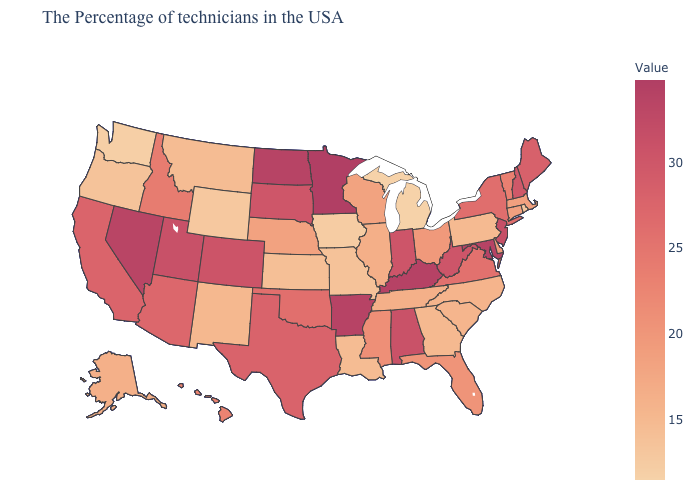Which states have the lowest value in the USA?
Keep it brief. Michigan. Does Delaware have the lowest value in the USA?
Give a very brief answer. No. Among the states that border North Carolina , does South Carolina have the lowest value?
Write a very short answer. No. Does Michigan have the lowest value in the USA?
Concise answer only. Yes. Is the legend a continuous bar?
Give a very brief answer. Yes. Does New Mexico have a higher value than New Jersey?
Short answer required. No. Which states hav the highest value in the South?
Short answer required. Kentucky. 